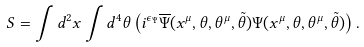<formula> <loc_0><loc_0><loc_500><loc_500>S = \int d ^ { 2 } x \int d ^ { 4 } \theta \left ( i ^ { \epsilon _ { \Psi } } \overline { \Psi } ( x ^ { \mu } , \theta , \theta ^ { \mu } , \tilde { \theta } ) { \Psi } ( x ^ { \mu } , \theta , \theta ^ { \mu } , \tilde { \theta } ) \right ) .</formula> 